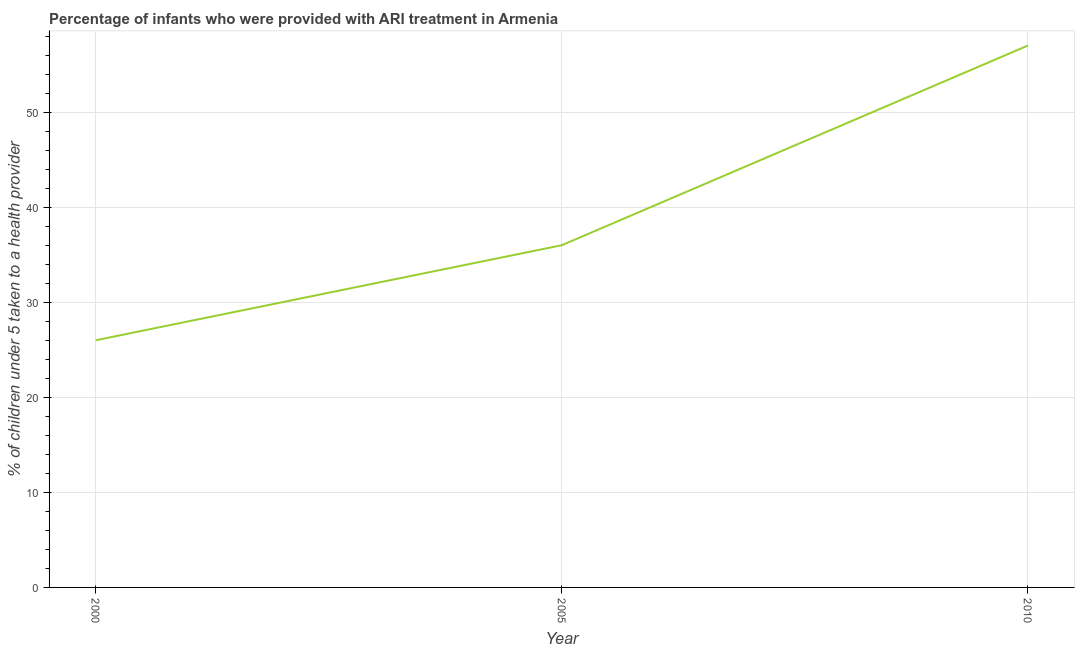What is the percentage of children who were provided with ari treatment in 2000?
Your answer should be very brief. 26. Across all years, what is the maximum percentage of children who were provided with ari treatment?
Make the answer very short. 57. Across all years, what is the minimum percentage of children who were provided with ari treatment?
Offer a terse response. 26. What is the sum of the percentage of children who were provided with ari treatment?
Ensure brevity in your answer.  119. What is the difference between the percentage of children who were provided with ari treatment in 2005 and 2010?
Keep it short and to the point. -21. What is the average percentage of children who were provided with ari treatment per year?
Offer a terse response. 39.67. In how many years, is the percentage of children who were provided with ari treatment greater than 28 %?
Provide a succinct answer. 2. Do a majority of the years between 2000 and 2005 (inclusive) have percentage of children who were provided with ari treatment greater than 46 %?
Provide a short and direct response. No. What is the ratio of the percentage of children who were provided with ari treatment in 2000 to that in 2010?
Your answer should be very brief. 0.46. Is the percentage of children who were provided with ari treatment in 2005 less than that in 2010?
Provide a short and direct response. Yes. Is the difference between the percentage of children who were provided with ari treatment in 2000 and 2005 greater than the difference between any two years?
Your answer should be compact. No. What is the difference between the highest and the lowest percentage of children who were provided with ari treatment?
Provide a succinct answer. 31. Does the percentage of children who were provided with ari treatment monotonically increase over the years?
Keep it short and to the point. Yes. How many years are there in the graph?
Keep it short and to the point. 3. What is the difference between two consecutive major ticks on the Y-axis?
Your answer should be very brief. 10. Are the values on the major ticks of Y-axis written in scientific E-notation?
Offer a terse response. No. What is the title of the graph?
Offer a very short reply. Percentage of infants who were provided with ARI treatment in Armenia. What is the label or title of the Y-axis?
Give a very brief answer. % of children under 5 taken to a health provider. What is the % of children under 5 taken to a health provider in 2000?
Give a very brief answer. 26. What is the % of children under 5 taken to a health provider in 2005?
Your answer should be compact. 36. What is the difference between the % of children under 5 taken to a health provider in 2000 and 2010?
Provide a succinct answer. -31. What is the ratio of the % of children under 5 taken to a health provider in 2000 to that in 2005?
Offer a terse response. 0.72. What is the ratio of the % of children under 5 taken to a health provider in 2000 to that in 2010?
Your response must be concise. 0.46. What is the ratio of the % of children under 5 taken to a health provider in 2005 to that in 2010?
Give a very brief answer. 0.63. 